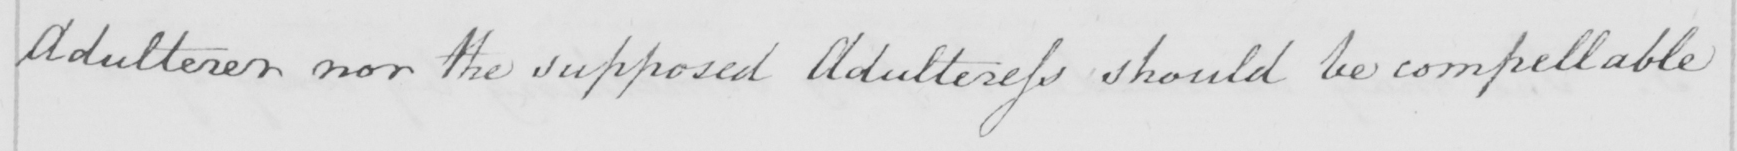Transcribe the text shown in this historical manuscript line. Adulterer nor the supposed Adulteress should be compellable 